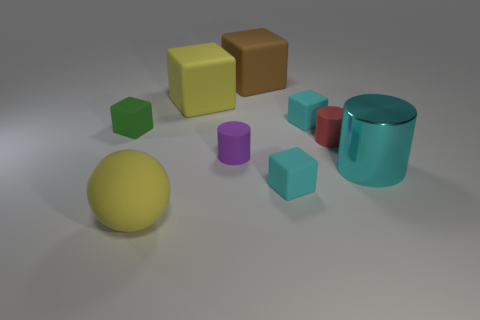What shape is the large thing that is on the right side of the brown rubber block?
Your answer should be very brief. Cylinder. There is a green rubber block; is it the same size as the yellow thing in front of the large metal object?
Your answer should be very brief. No. Is there another large sphere that has the same material as the yellow ball?
Keep it short and to the point. No. How many cylinders are small purple things or small matte objects?
Give a very brief answer. 2. Are there any cubes that are in front of the small cyan cube that is behind the small green matte thing?
Give a very brief answer. Yes. Are there fewer tiny green rubber cubes than gray rubber blocks?
Give a very brief answer. No. How many small green things are the same shape as the large cyan thing?
Offer a very short reply. 0. How many blue objects are big shiny cylinders or small cubes?
Ensure brevity in your answer.  0. What size is the rubber thing in front of the small cyan thing in front of the red cylinder?
Ensure brevity in your answer.  Large. What material is the tiny purple thing that is the same shape as the small red thing?
Give a very brief answer. Rubber. 